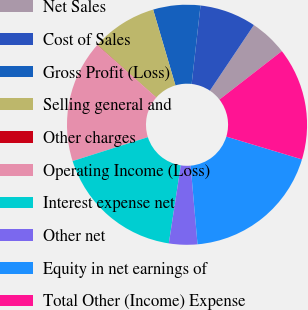Convert chart. <chart><loc_0><loc_0><loc_500><loc_500><pie_chart><fcel>Net Sales<fcel>Cost of Sales<fcel>Gross Profit (Loss)<fcel>Selling general and<fcel>Other charges<fcel>Operating Income (Loss)<fcel>Interest expense net<fcel>Other net<fcel>Equity in net earnings of<fcel>Total Other (Income) Expense<nl><fcel>5.09%<fcel>7.61%<fcel>6.35%<fcel>8.87%<fcel>0.04%<fcel>16.43%<fcel>17.69%<fcel>3.82%<fcel>18.95%<fcel>15.17%<nl></chart> 